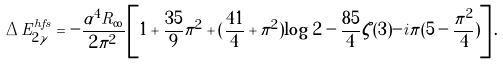<formula> <loc_0><loc_0><loc_500><loc_500>\Delta E ^ { h f s } _ { 2 \gamma } = - \frac { \alpha ^ { 4 } R _ { \infty } } { 2 \pi ^ { 2 } } \left [ 1 + \frac { 3 5 } { 9 } \pi ^ { 2 } + ( \frac { 4 1 } { 4 } + \pi ^ { 2 } ) \log \, 2 - \frac { 8 5 } { 4 } \zeta ( 3 ) - i \pi ( 5 - \frac { \pi ^ { 2 } } { 4 } ) \right ] .</formula> 